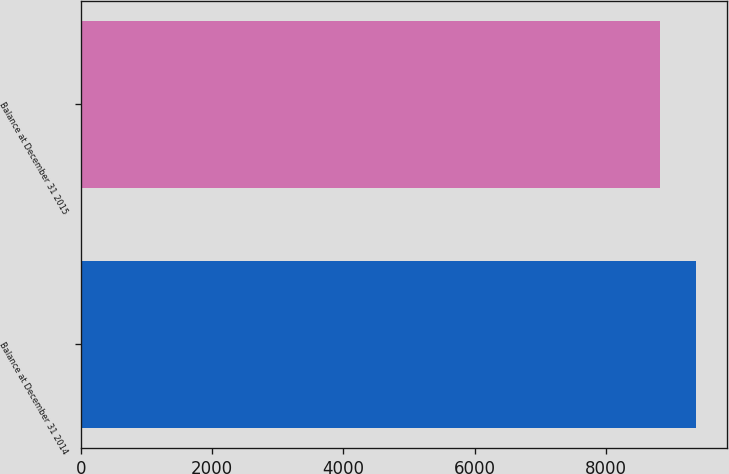<chart> <loc_0><loc_0><loc_500><loc_500><bar_chart><fcel>Balance at December 31 2014<fcel>Balance at December 31 2015<nl><fcel>9379<fcel>8834<nl></chart> 